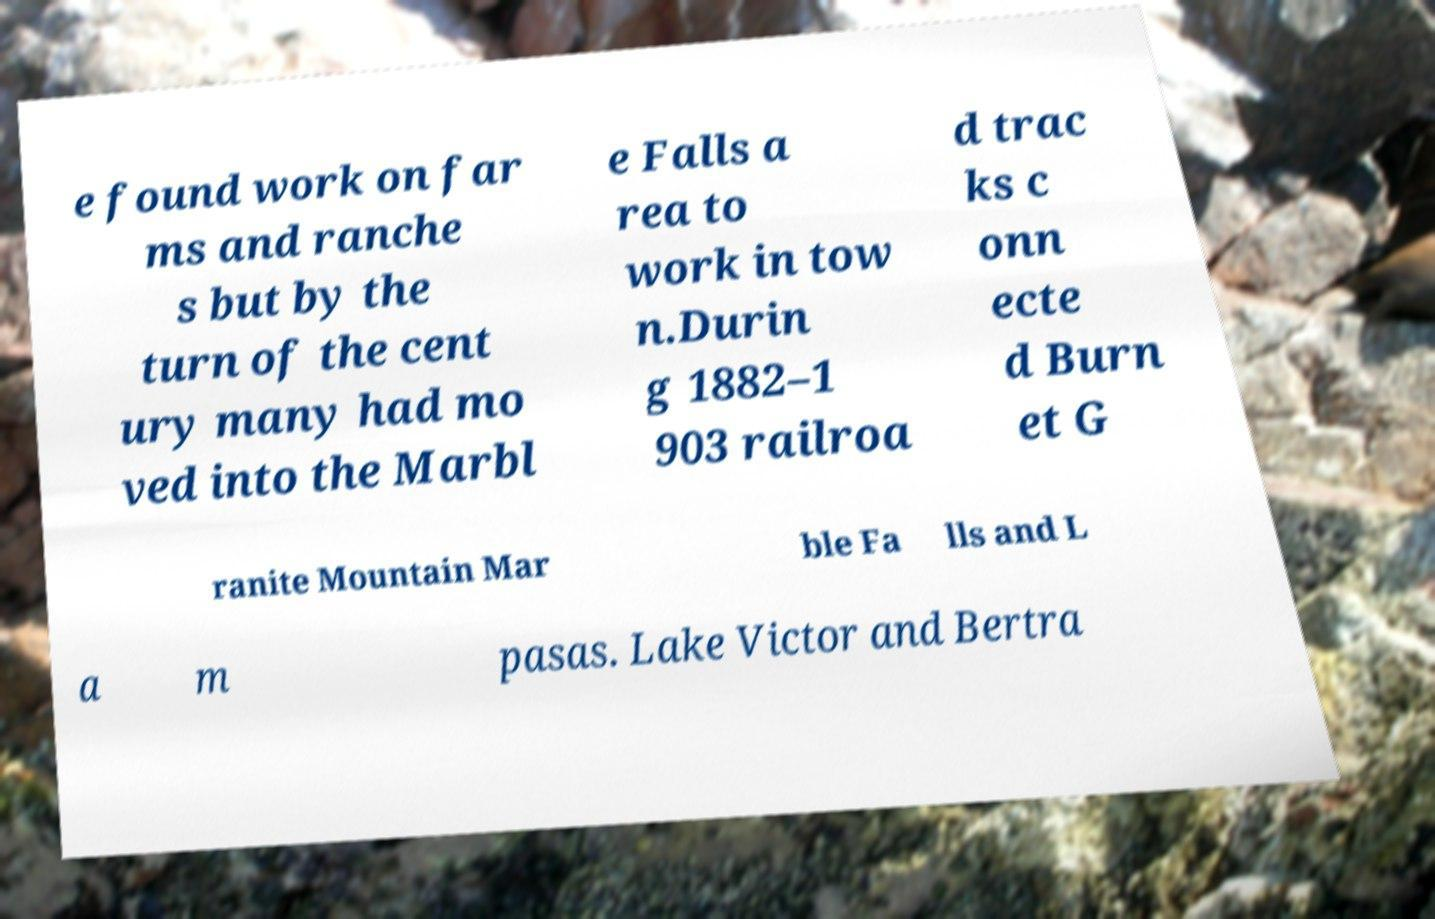Please read and relay the text visible in this image. What does it say? e found work on far ms and ranche s but by the turn of the cent ury many had mo ved into the Marbl e Falls a rea to work in tow n.Durin g 1882–1 903 railroa d trac ks c onn ecte d Burn et G ranite Mountain Mar ble Fa lls and L a m pasas. Lake Victor and Bertra 